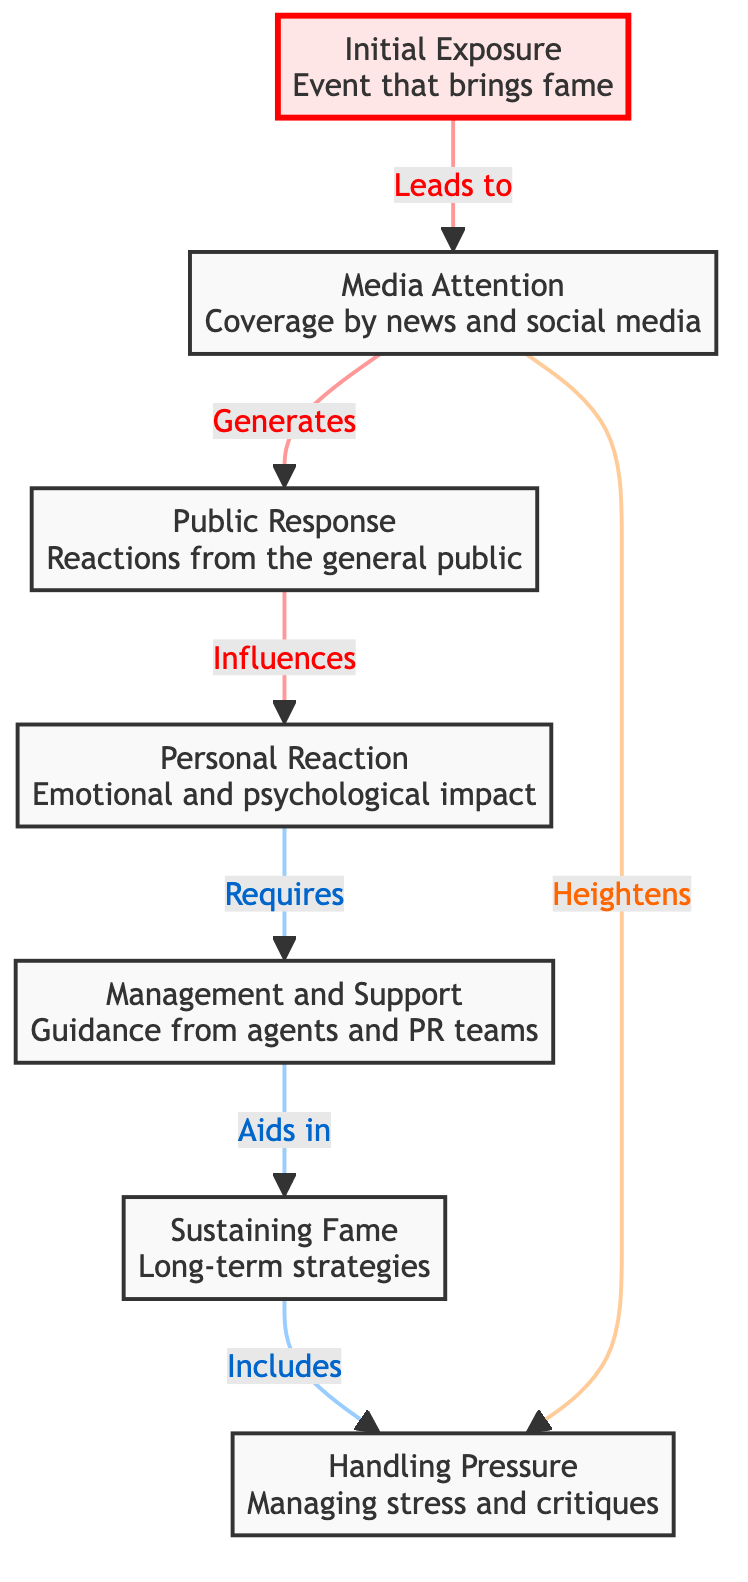What is the first stage in the diagram? The diagram lists "Initial Exposure" as the first node. This is the starting point that leads to other stages in the flowchart.
Answer: Initial Exposure How many total stages are present in the diagram? By counting the nodes in the flowchart, I see there are seven distinct stages: Initial Exposure, Media Attention, Public Response, Personal Reaction, Management and Support, Sustaining Fame, and Handling Pressure.
Answer: Seven What follows Media Attention in the flowchart? The flowchart indicates that after Media Attention, the next stage is Public Response. This is directly linked to the Media Attention node.
Answer: Public Response Which node indicates an emotional impact? The "Personal Reaction" node describes the emotional and psychological impact experienced by individuals. This clearly represents the emotional aspect related to sudden fame.
Answer: Personal Reaction What role does Management and Support play in the flowchart? The Management and Support node serves as guidance provided by agents and PR teams, which aids in the Sustaining Fame stage that follows it.
Answer: Guidance How does Public Response influence Personal Reaction? The flowchart shows a directional arrow from Public Response to Personal Reaction, indicating that the reactions from the public have a significant influence on the emotional and psychological impact on individuals.
Answer: Influences What two stages are connected directly to the Handling Pressure node? The Handling Pressure node is shown to receive input from the Sustaining Fame stage and is also heightened by Media Attention. These connections suggest that sustaining fame often comes with pressure, which is influenced by media coverage.
Answer: Sustaining Fame and Media Attention What is the last node in the flowchart? The final node in the flowchart is "Handling Pressure," indicating the last stage of processing and dealing with the pressures that come with sudden fame.
Answer: Handling Pressure 